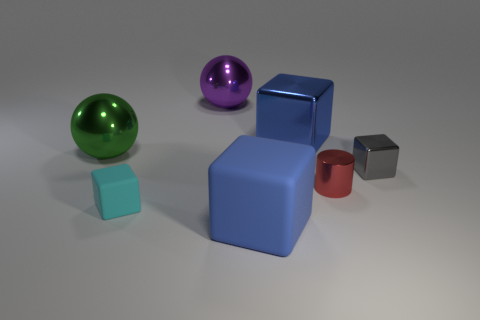Subtract 1 blocks. How many blocks are left? 3 Add 1 green cylinders. How many objects exist? 8 Subtract all spheres. How many objects are left? 5 Add 5 big purple shiny objects. How many big purple shiny objects are left? 6 Add 4 purple shiny spheres. How many purple shiny spheres exist? 5 Subtract 0 green cylinders. How many objects are left? 7 Subtract all small red metal objects. Subtract all cyan matte blocks. How many objects are left? 5 